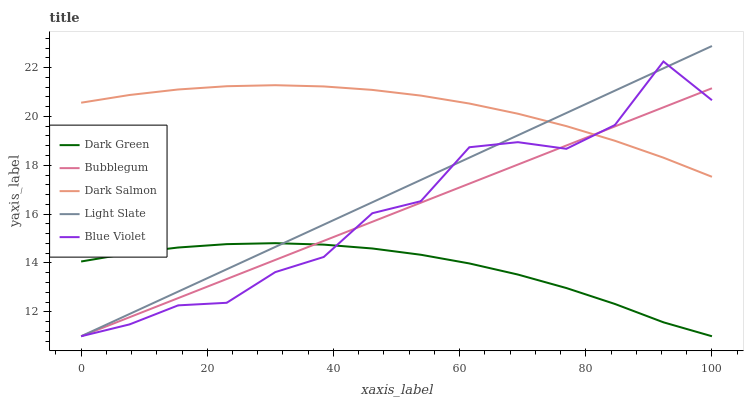Does Blue Violet have the minimum area under the curve?
Answer yes or no. No. Does Blue Violet have the maximum area under the curve?
Answer yes or no. No. Is Dark Salmon the smoothest?
Answer yes or no. No. Is Dark Salmon the roughest?
Answer yes or no. No. Does Dark Salmon have the lowest value?
Answer yes or no. No. Does Blue Violet have the highest value?
Answer yes or no. No. Is Dark Green less than Dark Salmon?
Answer yes or no. Yes. Is Dark Salmon greater than Dark Green?
Answer yes or no. Yes. Does Dark Green intersect Dark Salmon?
Answer yes or no. No. 